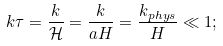<formula> <loc_0><loc_0><loc_500><loc_500>k \tau = \frac { k } { \mathcal { H } } = \frac { k } { a H } = \frac { k _ { p h y s } } { H } \ll 1 ;</formula> 